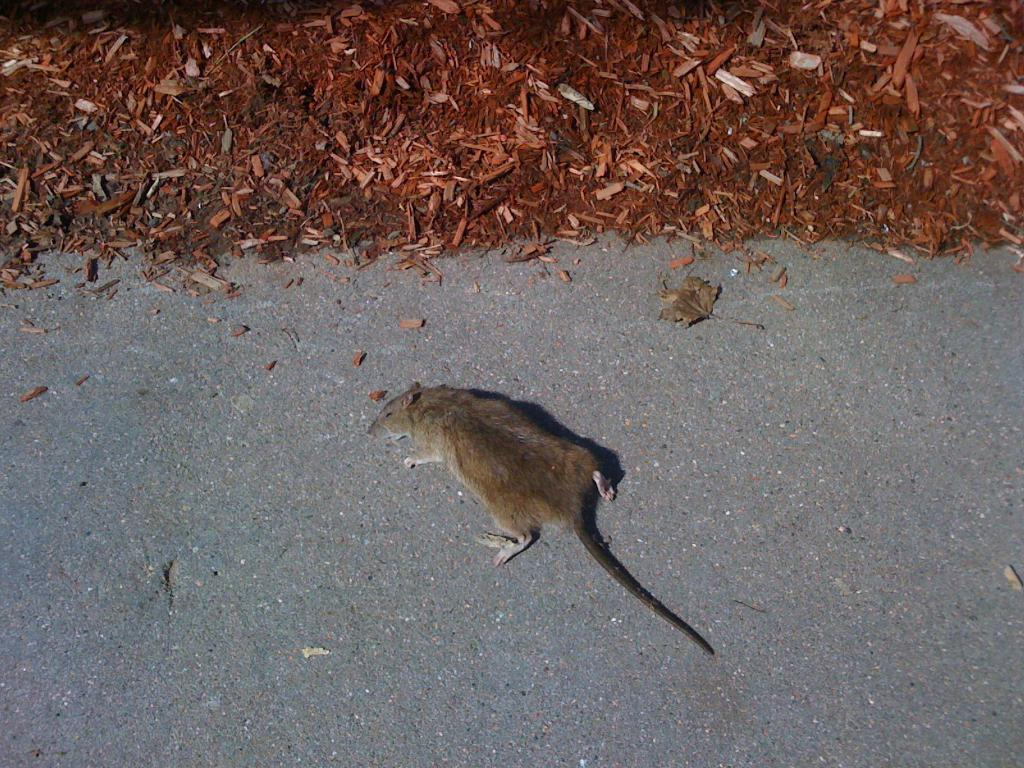What animal can be seen on the road in the image? There is a rat on the road in the image. What type of waste is present in the image? There is wooden waste in the image. What type of natural object can be seen in the image? There is a dried leaf in the image. Where is the lunchroom located in the image? There is no mention of a lunchroom in the image; it only features a rat, wooden waste, and a dried leaf. How does the rat pull the wooden waste in the image? The rat does not pull the wooden waste in the image; it is stationary on the road. 